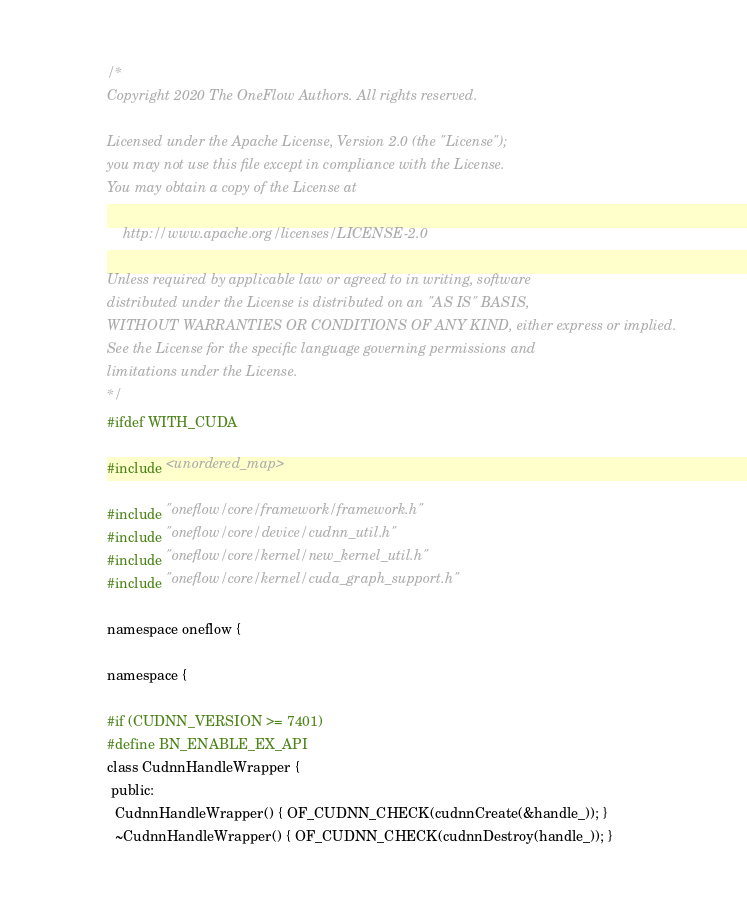<code> <loc_0><loc_0><loc_500><loc_500><_Cuda_>/*
Copyright 2020 The OneFlow Authors. All rights reserved.

Licensed under the Apache License, Version 2.0 (the "License");
you may not use this file except in compliance with the License.
You may obtain a copy of the License at

    http://www.apache.org/licenses/LICENSE-2.0

Unless required by applicable law or agreed to in writing, software
distributed under the License is distributed on an "AS IS" BASIS,
WITHOUT WARRANTIES OR CONDITIONS OF ANY KIND, either express or implied.
See the License for the specific language governing permissions and
limitations under the License.
*/
#ifdef WITH_CUDA

#include <unordered_map>

#include "oneflow/core/framework/framework.h"
#include "oneflow/core/device/cudnn_util.h"
#include "oneflow/core/kernel/new_kernel_util.h"
#include "oneflow/core/kernel/cuda_graph_support.h"

namespace oneflow {

namespace {

#if (CUDNN_VERSION >= 7401)
#define BN_ENABLE_EX_API
class CudnnHandleWrapper {
 public:
  CudnnHandleWrapper() { OF_CUDNN_CHECK(cudnnCreate(&handle_)); }
  ~CudnnHandleWrapper() { OF_CUDNN_CHECK(cudnnDestroy(handle_)); }
</code> 